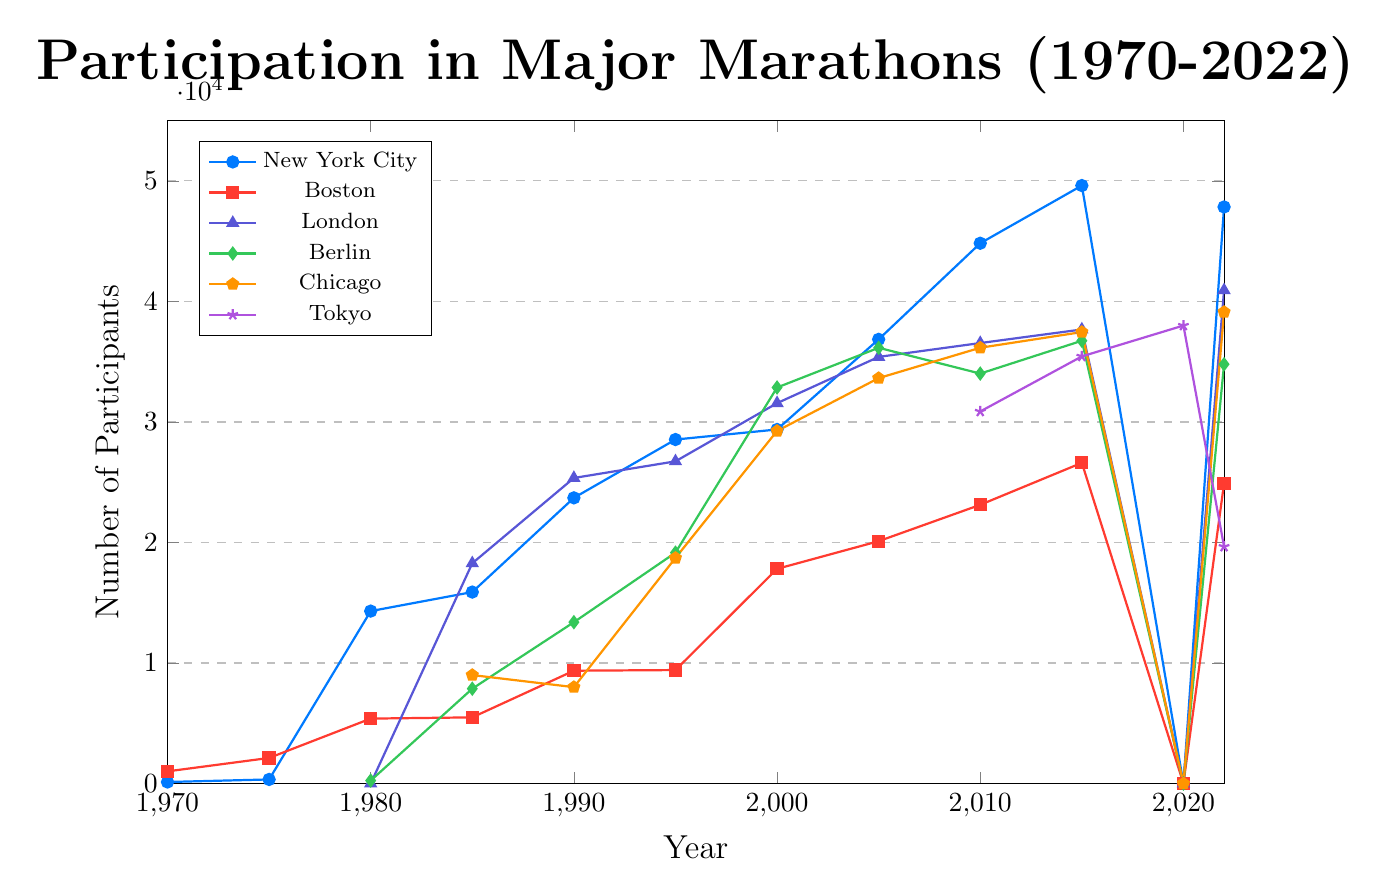What's the overall trend in New York City Marathon participation from 1970 to 2022? The data points for New York City Marathon show a consistent increase in participation from 127 in 1970 to a peak of 49617 in 2015, despite a drop to 0 in 2020 due to the likely impact of the COVID-19 pandemic, and it slightly recovered to 47839 in 2022.
Answer: Increasing with a significant drop in 2020 Which marathon had the highest number of participants in 2022? By looking at the last data point for each marathon, the London Marathon had the highest number of participants in 2022, with 40927 participants.
Answer: London Marathon How did participation in the Boston Marathon change from 2000 to 2022? The participation in the Boston Marathon increased from 17813 in 2000, peaking at 26610 in 2015, and then slightly decreased to 24918 in 2022.
Answer: Increased, then slightly decreased What is the difference in participation between the Berlin Marathon and the Chicago Marathon in 2015? The Berlin Marathon had 36739 participants in 2015, while the Chicago Marathon had 37459 participants. The difference is 37459 - 36739 = 720.
Answer: 720 Which marathon experienced the most significant drop in participation between 2015 and 2022? By looking at the changes between 2015 and 2022, the Tokyo Marathon experienced the most significant drop, from 35440 in 2015 to 19654 in 2022, a reduction of 35440 - 19654 = 15786 participants.
Answer: Tokyo Marathon Which marathon had a noticeable pattern of closing with zero participants in 2020? The data for the year 2020 shows a value of 0 for the New York City, Boston, London, Berlin, and Chicago Marathons. This indicates a noticeable pattern likely due to the pandemic's impact.
Answer: New York City, Boston, London, Berlin, and Chicago Marathons How does the participation rate in the New York City Marathon in 1980 compare to the Tokyo Marathon in 2022? The New York City Marathon had 14308 participants in 1980, while the Tokyo Marathon had 19654 participants in 2022. Thus, the Tokyo Marathon in 2022 had more participants than the New York City Marathon in 1980.
Answer: Tokyo Marathon in 2022 had more participants What is the average number of participants in the Chicago Marathon from 1985 to 2022? The participation numbers for the Chicago Marathon from 1985 to 2022 are 9000, 7998, 18716, 29256, 33639, 36159, 37459, and 39122. Summing these up: 9000 + 7998 + 18716 + 29256 + 33639 + 36159 + 37459 + 39122 = 210349. There are 8 data points, so the average is 210349 / 8 ≈ 26293.
Answer: 26293 What trends can you infer about the London Marathon between 2000 and 2022? Between 2000 and 2022, the participation in the London Marathon shows steady growth—from 31562 in 2000 to 40927 in 2022, except for the dip to 0 in 2020.
Answer: Steady growth with a dip in 2020 Which marathon had the lowest number of participants in 1980? In 1980, the New York City Marathon had 14308 participants, the Boston Marathon had 5388 participants, and the Berlin Marathon had 244 participants. Berlin Marathon had the lowest number.
Answer: Berlin Marathon 